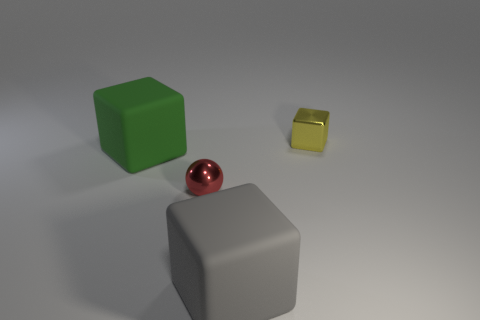Are there any large rubber blocks behind the big gray matte thing?
Keep it short and to the point. Yes. What number of other matte objects have the same shape as the large gray matte object?
Offer a terse response. 1. Is the big gray block made of the same material as the small object behind the small red shiny object?
Make the answer very short. No. What number of green matte cubes are there?
Give a very brief answer. 1. What size is the metallic object on the right side of the big gray cube?
Provide a succinct answer. Small. How many balls are the same size as the yellow metallic cube?
Keep it short and to the point. 1. What material is the object that is both in front of the green cube and behind the gray rubber thing?
Provide a succinct answer. Metal. What is the material of the ball that is the same size as the yellow metal object?
Give a very brief answer. Metal. What is the size of the yellow metal cube that is right of the object on the left side of the shiny thing left of the tiny block?
Your answer should be compact. Small. What is the size of the gray block that is made of the same material as the green block?
Make the answer very short. Large. 